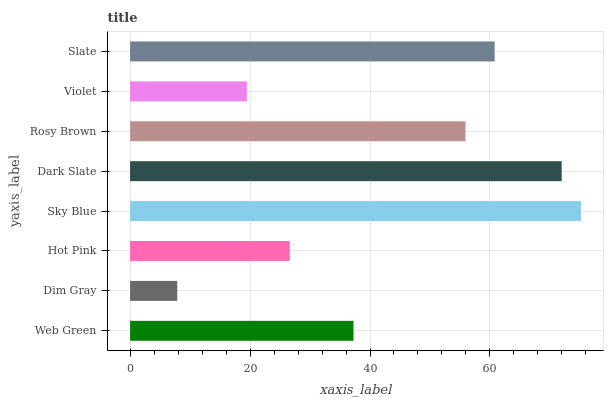Is Dim Gray the minimum?
Answer yes or no. Yes. Is Sky Blue the maximum?
Answer yes or no. Yes. Is Hot Pink the minimum?
Answer yes or no. No. Is Hot Pink the maximum?
Answer yes or no. No. Is Hot Pink greater than Dim Gray?
Answer yes or no. Yes. Is Dim Gray less than Hot Pink?
Answer yes or no. Yes. Is Dim Gray greater than Hot Pink?
Answer yes or no. No. Is Hot Pink less than Dim Gray?
Answer yes or no. No. Is Rosy Brown the high median?
Answer yes or no. Yes. Is Web Green the low median?
Answer yes or no. Yes. Is Hot Pink the high median?
Answer yes or no. No. Is Slate the low median?
Answer yes or no. No. 